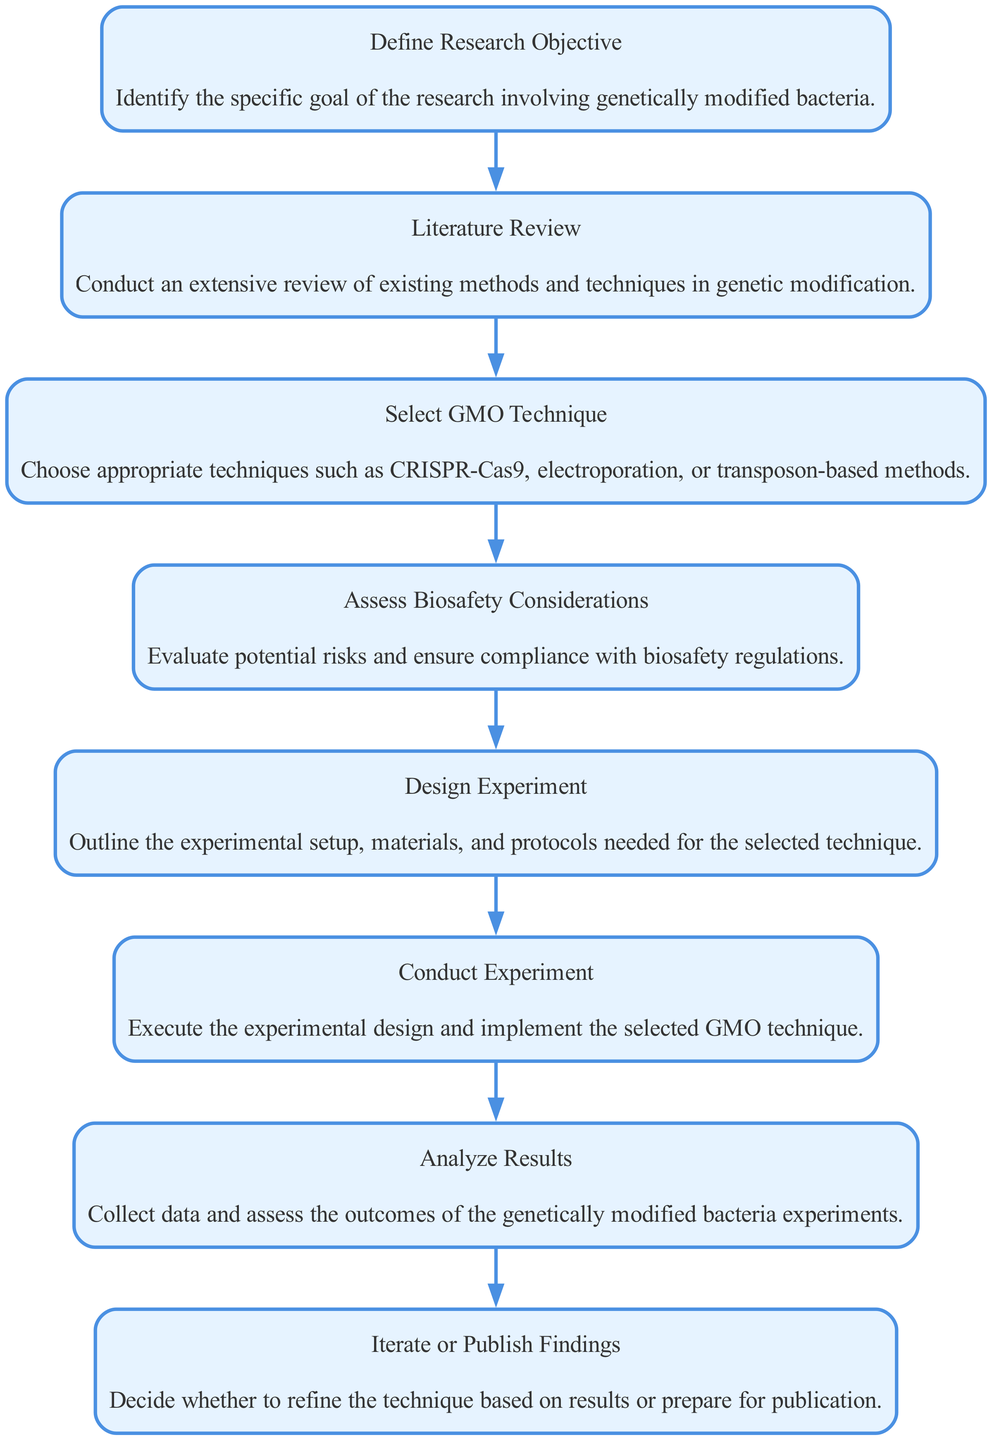What is the first step in the decision-making process? The first step in the decision-making process is "Define Research Objective," which is the initial node in the flow chart.
Answer: Define Research Objective How many steps are there in total in the flow chart? By counting each of the nodes listed in the decision-making process, we find there are eight distinct steps.
Answer: 8 What technique is chosen in the selection process? The step that involves technique selection is labeled "Select GMO Technique," which is the third step of the flow chart.
Answer: Select GMO Technique What is evaluated after selecting a GMO technique? The step following technique selection is "Assess Biosafety Considerations," which evaluates potential risks.
Answer: Assess Biosafety Considerations If the experiment results are unsatisfactory, what happens next? Following the "Analyze Results" step, if the outcomes require refinement, the decision is to "Iterate or Publish Findings," indicating a potential for revision before publication.
Answer: Iterate or Publish Findings What step involves experimental design? The step that details the experimental setup and protocols is "Design Experiment," which is the fifth node defined in the process.
Answer: Design Experiment Which step is directly before "Conduct Experiment"? The step prior to "Conduct Experiment" is "Design Experiment," as seen in the sequential flow of the diagram.
Answer: Design Experiment What is the primary focus of the "Literature Review" step? The goal of the "Literature Review" step is to gather existing information on genetic modification techniques, which informs later decisions in the process.
Answer: Conduct an extensive review of existing methods and techniques in genetic modification 